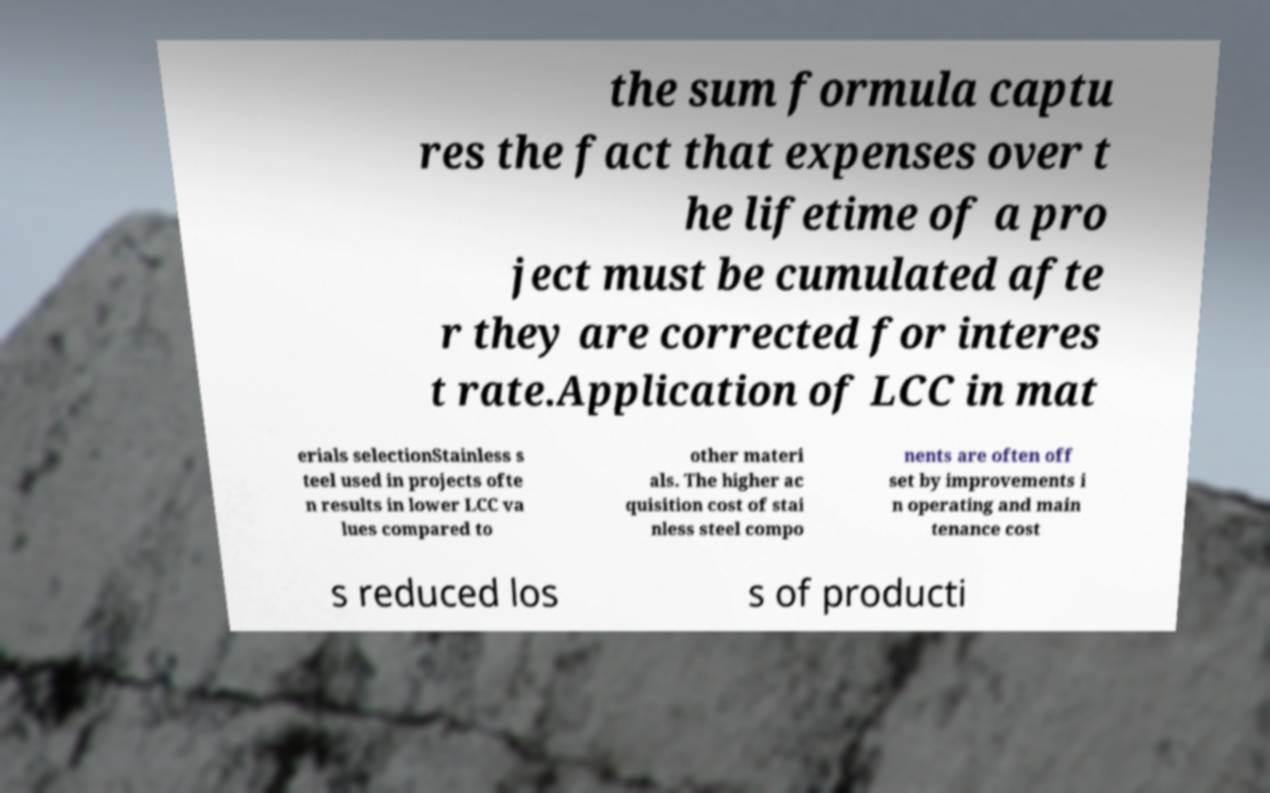Can you accurately transcribe the text from the provided image for me? the sum formula captu res the fact that expenses over t he lifetime of a pro ject must be cumulated afte r they are corrected for interes t rate.Application of LCC in mat erials selectionStainless s teel used in projects ofte n results in lower LCC va lues compared to other materi als. The higher ac quisition cost of stai nless steel compo nents are often off set by improvements i n operating and main tenance cost s reduced los s of producti 